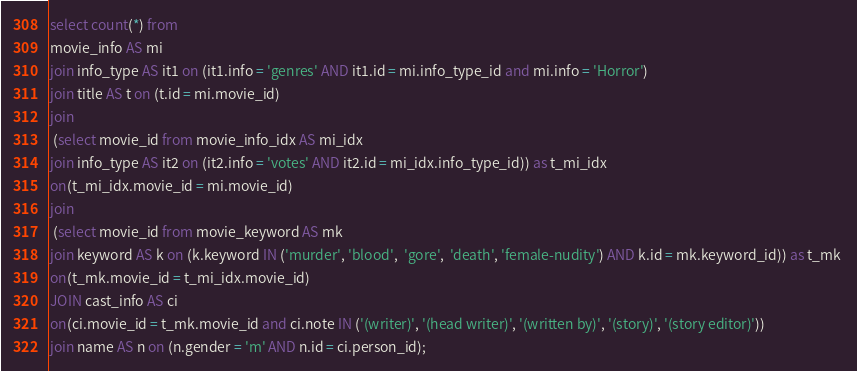Convert code to text. <code><loc_0><loc_0><loc_500><loc_500><_SQL_>select count(*) from 
movie_info AS mi 
join info_type AS it1 on (it1.info = 'genres' AND it1.id = mi.info_type_id and mi.info = 'Horror')
join title AS t on (t.id = mi.movie_id)
join
 (select movie_id from movie_info_idx AS mi_idx 
join info_type AS it2 on (it2.info = 'votes' AND it2.id = mi_idx.info_type_id)) as t_mi_idx 
on(t_mi_idx.movie_id = mi.movie_id)
join
 (select movie_id from movie_keyword AS mk 
join keyword AS k on (k.keyword IN ('murder', 'blood',  'gore',  'death', 'female-nudity') AND k.id = mk.keyword_id)) as t_mk 
on(t_mk.movie_id = t_mi_idx.movie_id)
JOIN cast_info AS ci  
on(ci.movie_id = t_mk.movie_id and ci.note IN ('(writer)', '(head writer)', '(written by)', '(story)', '(story editor)'))
join name AS n on (n.gender = 'm' AND n.id = ci.person_id);</code> 